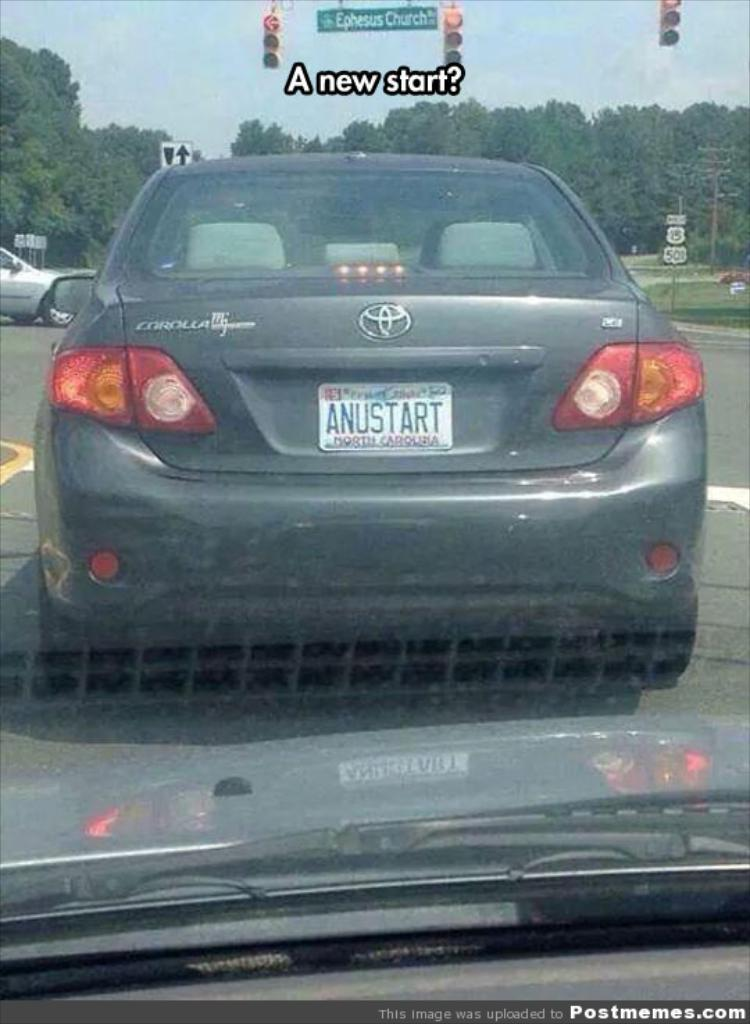<image>
Share a concise interpretation of the image provided. A grey car says Corolla and the license plate says Anustart. 